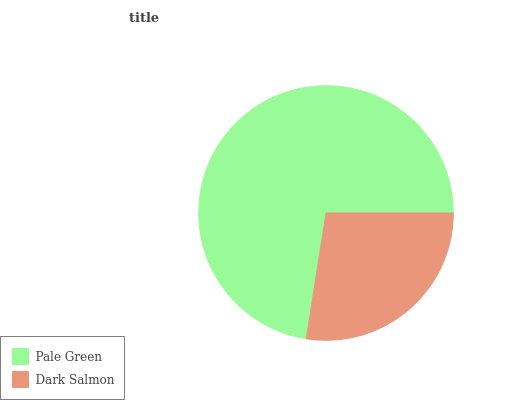Is Dark Salmon the minimum?
Answer yes or no. Yes. Is Pale Green the maximum?
Answer yes or no. Yes. Is Dark Salmon the maximum?
Answer yes or no. No. Is Pale Green greater than Dark Salmon?
Answer yes or no. Yes. Is Dark Salmon less than Pale Green?
Answer yes or no. Yes. Is Dark Salmon greater than Pale Green?
Answer yes or no. No. Is Pale Green less than Dark Salmon?
Answer yes or no. No. Is Pale Green the high median?
Answer yes or no. Yes. Is Dark Salmon the low median?
Answer yes or no. Yes. Is Dark Salmon the high median?
Answer yes or no. No. Is Pale Green the low median?
Answer yes or no. No. 